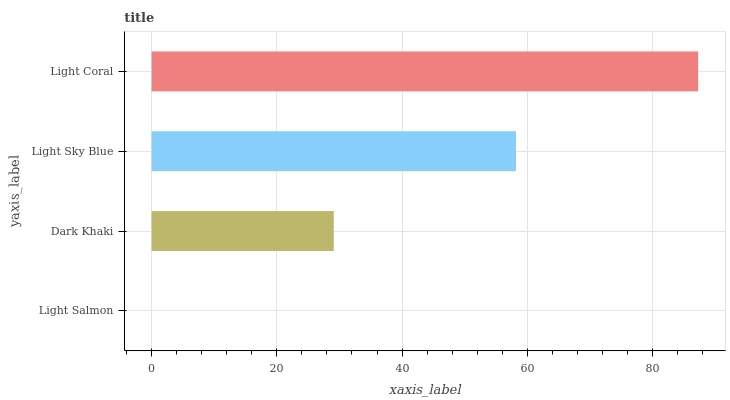Is Light Salmon the minimum?
Answer yes or no. Yes. Is Light Coral the maximum?
Answer yes or no. Yes. Is Dark Khaki the minimum?
Answer yes or no. No. Is Dark Khaki the maximum?
Answer yes or no. No. Is Dark Khaki greater than Light Salmon?
Answer yes or no. Yes. Is Light Salmon less than Dark Khaki?
Answer yes or no. Yes. Is Light Salmon greater than Dark Khaki?
Answer yes or no. No. Is Dark Khaki less than Light Salmon?
Answer yes or no. No. Is Light Sky Blue the high median?
Answer yes or no. Yes. Is Dark Khaki the low median?
Answer yes or no. Yes. Is Dark Khaki the high median?
Answer yes or no. No. Is Light Salmon the low median?
Answer yes or no. No. 